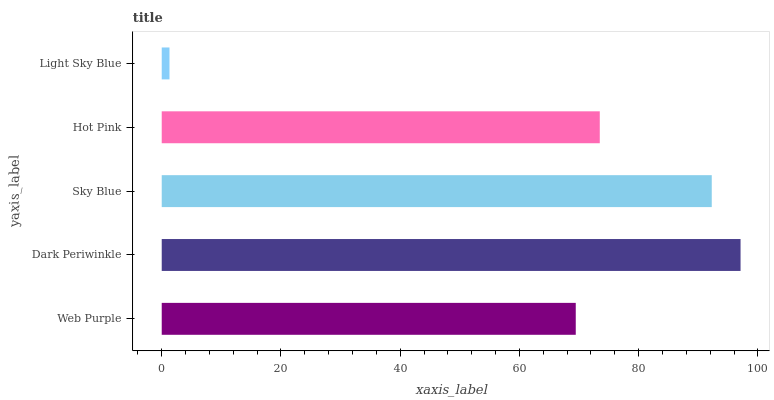Is Light Sky Blue the minimum?
Answer yes or no. Yes. Is Dark Periwinkle the maximum?
Answer yes or no. Yes. Is Sky Blue the minimum?
Answer yes or no. No. Is Sky Blue the maximum?
Answer yes or no. No. Is Dark Periwinkle greater than Sky Blue?
Answer yes or no. Yes. Is Sky Blue less than Dark Periwinkle?
Answer yes or no. Yes. Is Sky Blue greater than Dark Periwinkle?
Answer yes or no. No. Is Dark Periwinkle less than Sky Blue?
Answer yes or no. No. Is Hot Pink the high median?
Answer yes or no. Yes. Is Hot Pink the low median?
Answer yes or no. Yes. Is Light Sky Blue the high median?
Answer yes or no. No. Is Web Purple the low median?
Answer yes or no. No. 